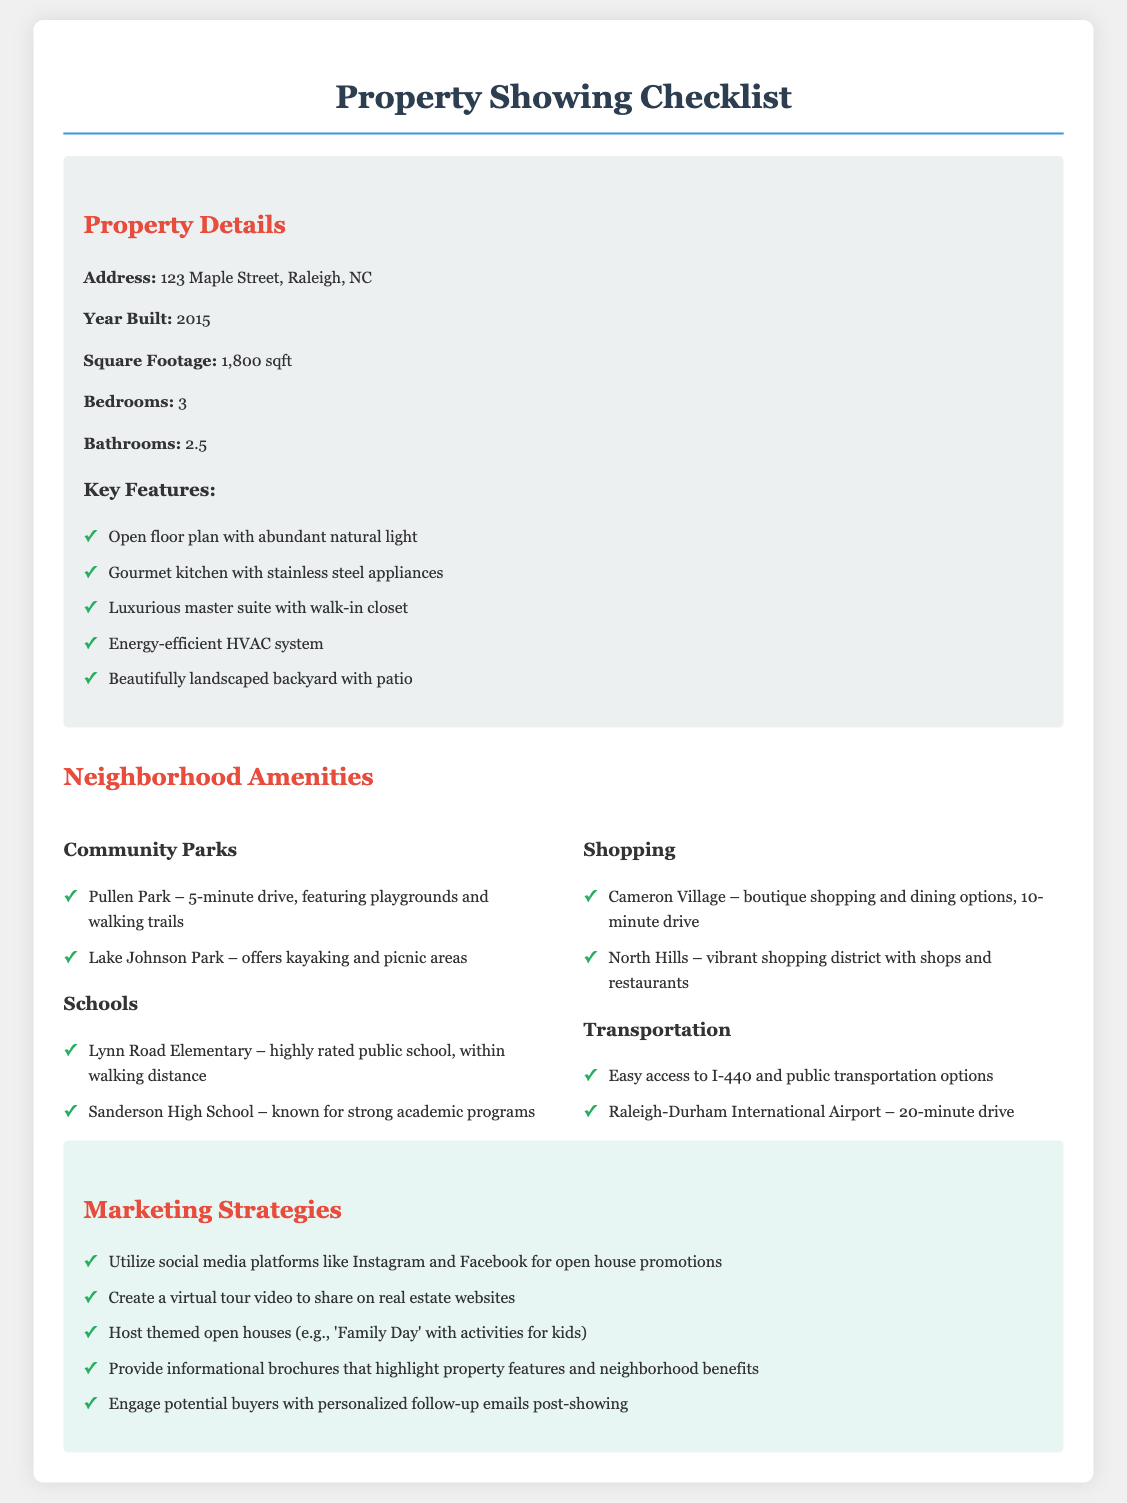what is the address of the property? The address of the property is specified in the document as the primary identifier of the listing.
Answer: 123 Maple Street, Raleigh, NC how many bedrooms are in the house? The document provides a specific number of bedrooms available in the property section.
Answer: 3 what year was the property built? The construction year is mentioned in the property details section.
Answer: 2015 what is the square footage of the property? The size of the property is also included in the details for potential buyers to evaluate space.
Answer: 1,800 sqft which park is a 5-minute drive away? The document lists a particular park along with its distance from the property, reflecting local amenities.
Answer: Pullen Park what is the name of the highly rated public school? A specific school is mentioned that is easily accessible for families living in the neighborhood.
Answer: Lynn Road Elementary how far is Raleigh-Durham International Airport from the property? The travel distance to the airport is specified, giving insights into transportation options.
Answer: 20-minute drive what is one marketing strategy mentioned? The document outlines various strategies for promoting the property, demonstrating proactive marketing efforts.
Answer: Utilize social media platforms how many bathrooms are in the property? The number of bathrooms is a critical detail noted in the property overview for potential buyers.
Answer: 2.5 what feature is highlighted about the master suite? A specific distinctive feature related to the master suite is included, which may appeal to buyers.
Answer: Walk-in closet 